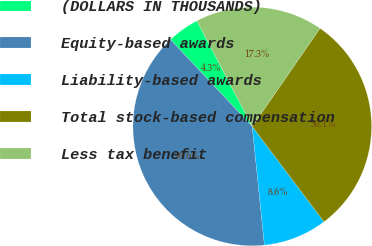Convert chart to OTSL. <chart><loc_0><loc_0><loc_500><loc_500><pie_chart><fcel>(DOLLARS IN THOUSANDS)<fcel>Equity-based awards<fcel>Liability-based awards<fcel>Total stock-based compensation<fcel>Less tax benefit<nl><fcel>4.33%<fcel>39.61%<fcel>8.64%<fcel>30.11%<fcel>17.3%<nl></chart> 